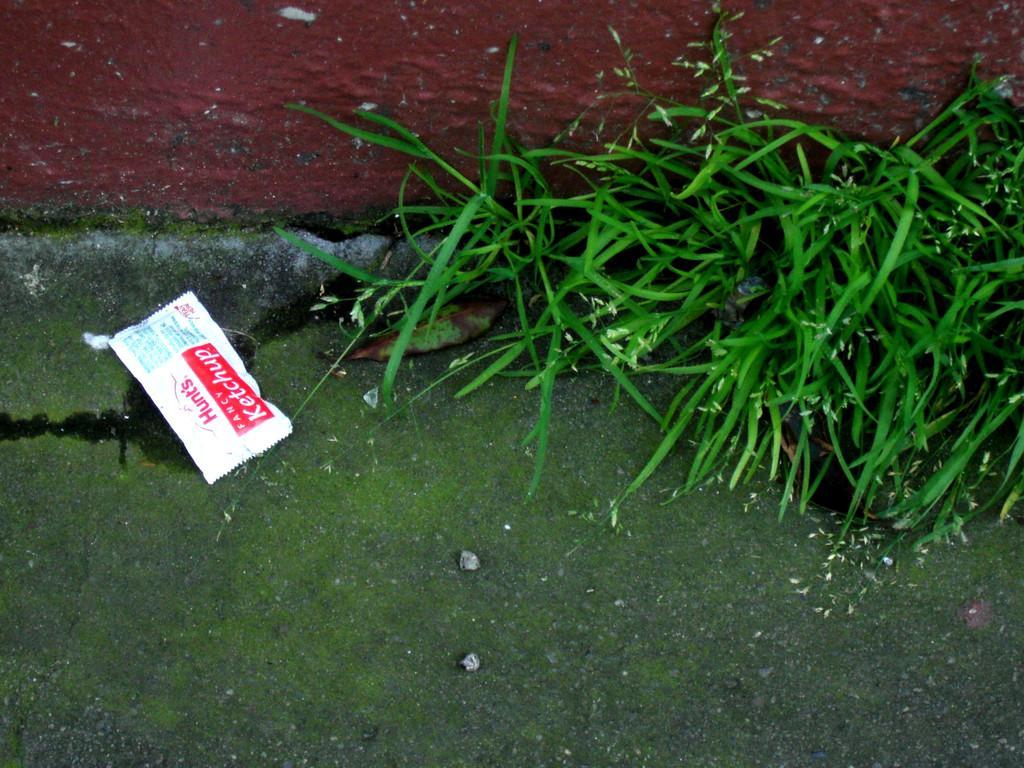How would you summarize this image in a sentence or two? These are plants, this is packet. 